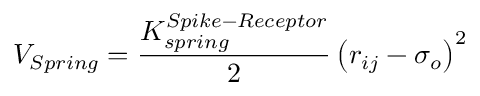Convert formula to latex. <formula><loc_0><loc_0><loc_500><loc_500>V _ { S p r i n g } = \frac { K _ { s p r i n g } ^ { S p i k e - R e c e p t o r } } { 2 } \left ( r _ { i j } - \sigma _ { o } \right ) ^ { 2 }</formula> 